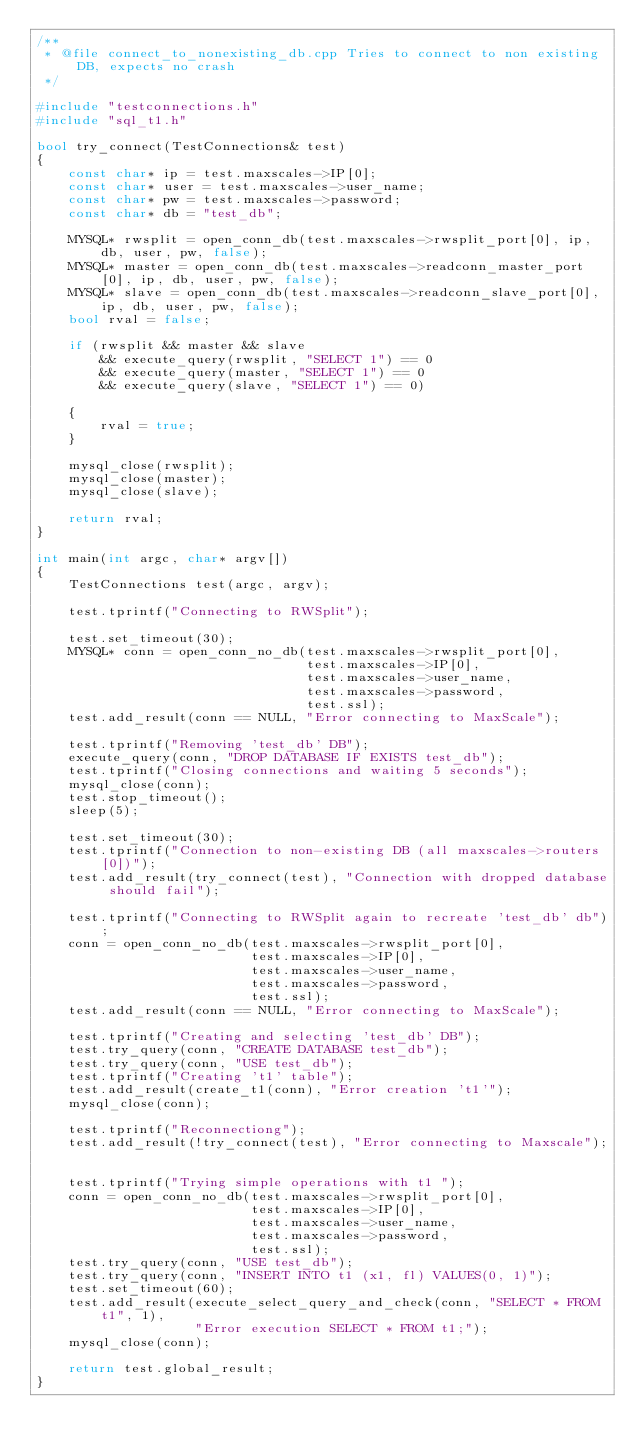Convert code to text. <code><loc_0><loc_0><loc_500><loc_500><_C++_>/**
 * @file connect_to_nonexisting_db.cpp Tries to connect to non existing DB, expects no crash
 */

#include "testconnections.h"
#include "sql_t1.h"

bool try_connect(TestConnections& test)
{
    const char* ip = test.maxscales->IP[0];
    const char* user = test.maxscales->user_name;
    const char* pw = test.maxscales->password;
    const char* db = "test_db";

    MYSQL* rwsplit = open_conn_db(test.maxscales->rwsplit_port[0], ip, db, user, pw, false);
    MYSQL* master = open_conn_db(test.maxscales->readconn_master_port[0], ip, db, user, pw, false);
    MYSQL* slave = open_conn_db(test.maxscales->readconn_slave_port[0], ip, db, user, pw, false);
    bool rval = false;

    if (rwsplit && master && slave
        && execute_query(rwsplit, "SELECT 1") == 0
        && execute_query(master, "SELECT 1") == 0
        && execute_query(slave, "SELECT 1") == 0)

    {
        rval = true;
    }

    mysql_close(rwsplit);
    mysql_close(master);
    mysql_close(slave);

    return rval;
}

int main(int argc, char* argv[])
{
    TestConnections test(argc, argv);

    test.tprintf("Connecting to RWSplit");

    test.set_timeout(30);
    MYSQL* conn = open_conn_no_db(test.maxscales->rwsplit_port[0],
                                  test.maxscales->IP[0],
                                  test.maxscales->user_name,
                                  test.maxscales->password,
                                  test.ssl);
    test.add_result(conn == NULL, "Error connecting to MaxScale");

    test.tprintf("Removing 'test_db' DB");
    execute_query(conn, "DROP DATABASE IF EXISTS test_db");
    test.tprintf("Closing connections and waiting 5 seconds");
    mysql_close(conn);
    test.stop_timeout();
    sleep(5);

    test.set_timeout(30);
    test.tprintf("Connection to non-existing DB (all maxscales->routers[0])");
    test.add_result(try_connect(test), "Connection with dropped database should fail");

    test.tprintf("Connecting to RWSplit again to recreate 'test_db' db");
    conn = open_conn_no_db(test.maxscales->rwsplit_port[0],
                           test.maxscales->IP[0],
                           test.maxscales->user_name,
                           test.maxscales->password,
                           test.ssl);
    test.add_result(conn == NULL, "Error connecting to MaxScale");

    test.tprintf("Creating and selecting 'test_db' DB");
    test.try_query(conn, "CREATE DATABASE test_db");
    test.try_query(conn, "USE test_db");
    test.tprintf("Creating 't1' table");
    test.add_result(create_t1(conn), "Error creation 't1'");
    mysql_close(conn);

    test.tprintf("Reconnectiong");
    test.add_result(!try_connect(test), "Error connecting to Maxscale");


    test.tprintf("Trying simple operations with t1 ");
    conn = open_conn_no_db(test.maxscales->rwsplit_port[0],
                           test.maxscales->IP[0],
                           test.maxscales->user_name,
                           test.maxscales->password,
                           test.ssl);
    test.try_query(conn, "USE test_db");
    test.try_query(conn, "INSERT INTO t1 (x1, fl) VALUES(0, 1)");
    test.set_timeout(60);
    test.add_result(execute_select_query_and_check(conn, "SELECT * FROM t1", 1),
                    "Error execution SELECT * FROM t1;");
    mysql_close(conn);

    return test.global_result;
}
</code> 